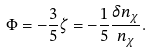Convert formula to latex. <formula><loc_0><loc_0><loc_500><loc_500>\Phi = - \frac { 3 } { 5 } \zeta = - \frac { 1 } { 5 } \frac { \delta n _ { \chi } } { n _ { \chi } } .</formula> 